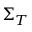Convert formula to latex. <formula><loc_0><loc_0><loc_500><loc_500>\Sigma _ { T }</formula> 